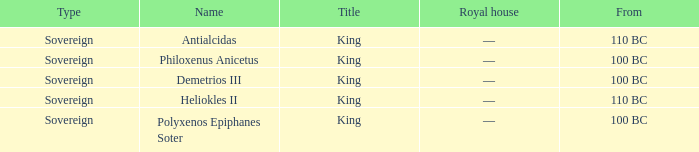When did Demetrios III begin to hold power? 100 BC. 